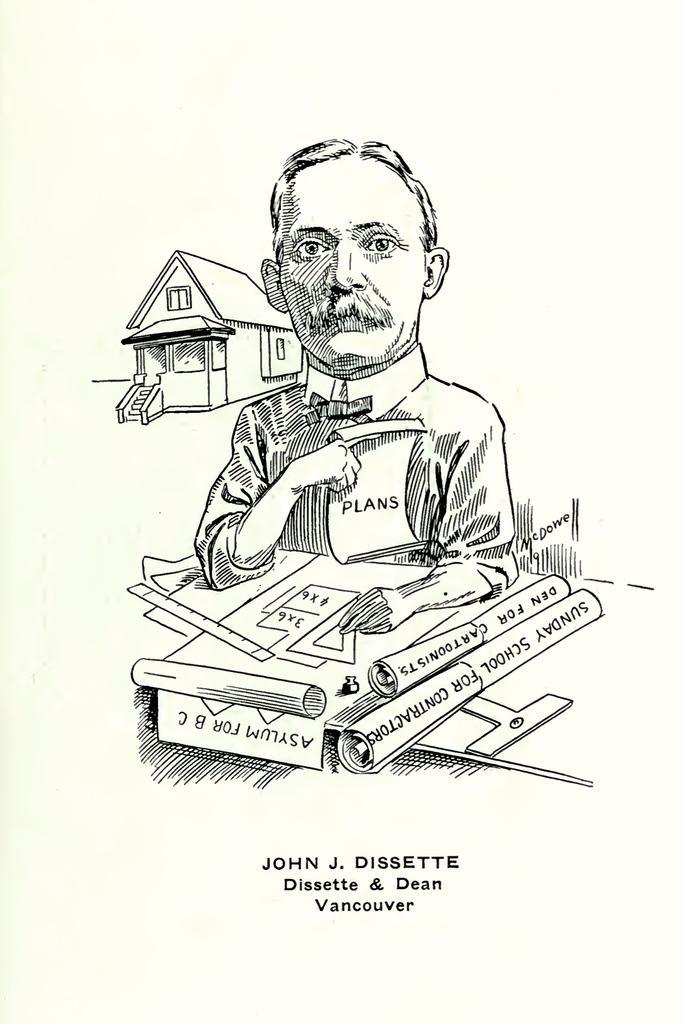Could you give a brief overview of what you see in this image? In this image we can see a drawing. In the drawing we can see a person, a house and many objects in the image. Some text written at the bottom of the image. 